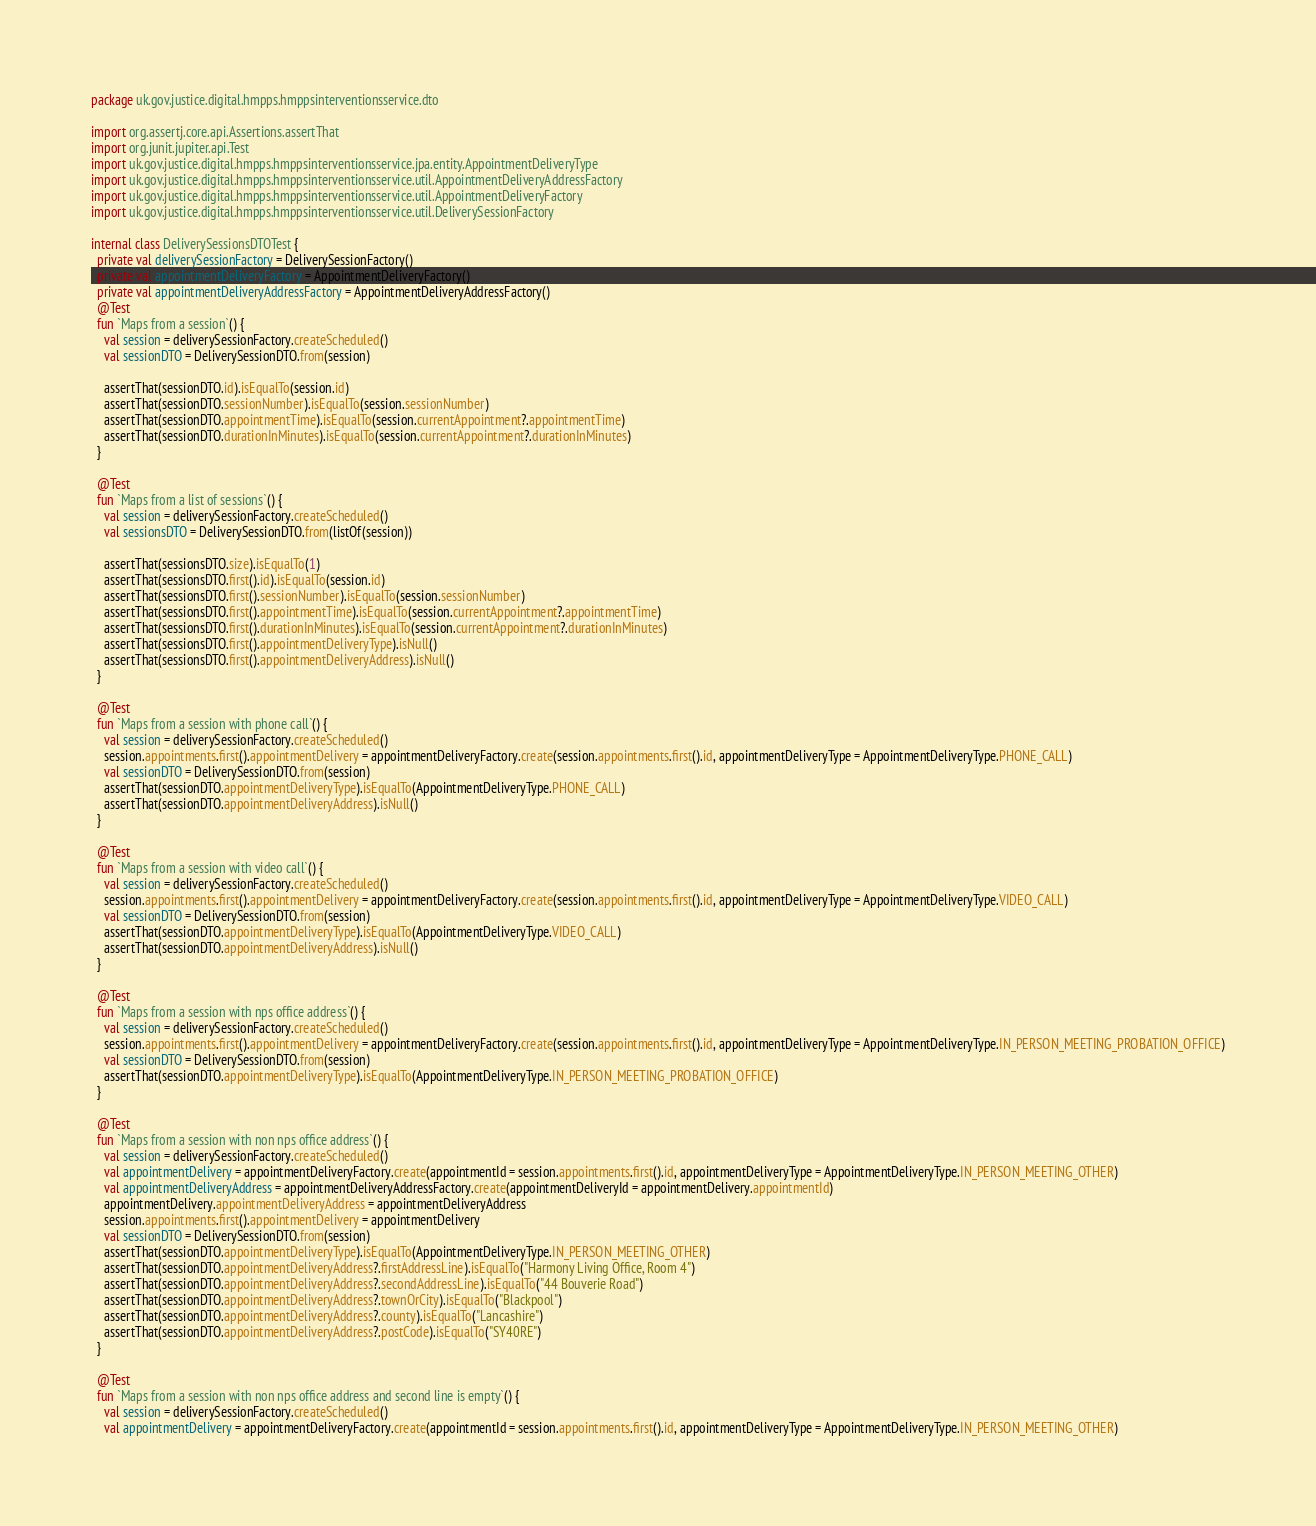Convert code to text. <code><loc_0><loc_0><loc_500><loc_500><_Kotlin_>package uk.gov.justice.digital.hmpps.hmppsinterventionsservice.dto

import org.assertj.core.api.Assertions.assertThat
import org.junit.jupiter.api.Test
import uk.gov.justice.digital.hmpps.hmppsinterventionsservice.jpa.entity.AppointmentDeliveryType
import uk.gov.justice.digital.hmpps.hmppsinterventionsservice.util.AppointmentDeliveryAddressFactory
import uk.gov.justice.digital.hmpps.hmppsinterventionsservice.util.AppointmentDeliveryFactory
import uk.gov.justice.digital.hmpps.hmppsinterventionsservice.util.DeliverySessionFactory

internal class DeliverySessionsDTOTest {
  private val deliverySessionFactory = DeliverySessionFactory()
  private val appointmentDeliveryFactory = AppointmentDeliveryFactory()
  private val appointmentDeliveryAddressFactory = AppointmentDeliveryAddressFactory()
  @Test
  fun `Maps from a session`() {
    val session = deliverySessionFactory.createScheduled()
    val sessionDTO = DeliverySessionDTO.from(session)

    assertThat(sessionDTO.id).isEqualTo(session.id)
    assertThat(sessionDTO.sessionNumber).isEqualTo(session.sessionNumber)
    assertThat(sessionDTO.appointmentTime).isEqualTo(session.currentAppointment?.appointmentTime)
    assertThat(sessionDTO.durationInMinutes).isEqualTo(session.currentAppointment?.durationInMinutes)
  }

  @Test
  fun `Maps from a list of sessions`() {
    val session = deliverySessionFactory.createScheduled()
    val sessionsDTO = DeliverySessionDTO.from(listOf(session))

    assertThat(sessionsDTO.size).isEqualTo(1)
    assertThat(sessionsDTO.first().id).isEqualTo(session.id)
    assertThat(sessionsDTO.first().sessionNumber).isEqualTo(session.sessionNumber)
    assertThat(sessionsDTO.first().appointmentTime).isEqualTo(session.currentAppointment?.appointmentTime)
    assertThat(sessionsDTO.first().durationInMinutes).isEqualTo(session.currentAppointment?.durationInMinutes)
    assertThat(sessionsDTO.first().appointmentDeliveryType).isNull()
    assertThat(sessionsDTO.first().appointmentDeliveryAddress).isNull()
  }

  @Test
  fun `Maps from a session with phone call`() {
    val session = deliverySessionFactory.createScheduled()
    session.appointments.first().appointmentDelivery = appointmentDeliveryFactory.create(session.appointments.first().id, appointmentDeliveryType = AppointmentDeliveryType.PHONE_CALL)
    val sessionDTO = DeliverySessionDTO.from(session)
    assertThat(sessionDTO.appointmentDeliveryType).isEqualTo(AppointmentDeliveryType.PHONE_CALL)
    assertThat(sessionDTO.appointmentDeliveryAddress).isNull()
  }

  @Test
  fun `Maps from a session with video call`() {
    val session = deliverySessionFactory.createScheduled()
    session.appointments.first().appointmentDelivery = appointmentDeliveryFactory.create(session.appointments.first().id, appointmentDeliveryType = AppointmentDeliveryType.VIDEO_CALL)
    val sessionDTO = DeliverySessionDTO.from(session)
    assertThat(sessionDTO.appointmentDeliveryType).isEqualTo(AppointmentDeliveryType.VIDEO_CALL)
    assertThat(sessionDTO.appointmentDeliveryAddress).isNull()
  }

  @Test
  fun `Maps from a session with nps office address`() {
    val session = deliverySessionFactory.createScheduled()
    session.appointments.first().appointmentDelivery = appointmentDeliveryFactory.create(session.appointments.first().id, appointmentDeliveryType = AppointmentDeliveryType.IN_PERSON_MEETING_PROBATION_OFFICE)
    val sessionDTO = DeliverySessionDTO.from(session)
    assertThat(sessionDTO.appointmentDeliveryType).isEqualTo(AppointmentDeliveryType.IN_PERSON_MEETING_PROBATION_OFFICE)
  }

  @Test
  fun `Maps from a session with non nps office address`() {
    val session = deliverySessionFactory.createScheduled()
    val appointmentDelivery = appointmentDeliveryFactory.create(appointmentId = session.appointments.first().id, appointmentDeliveryType = AppointmentDeliveryType.IN_PERSON_MEETING_OTHER)
    val appointmentDeliveryAddress = appointmentDeliveryAddressFactory.create(appointmentDeliveryId = appointmentDelivery.appointmentId)
    appointmentDelivery.appointmentDeliveryAddress = appointmentDeliveryAddress
    session.appointments.first().appointmentDelivery = appointmentDelivery
    val sessionDTO = DeliverySessionDTO.from(session)
    assertThat(sessionDTO.appointmentDeliveryType).isEqualTo(AppointmentDeliveryType.IN_PERSON_MEETING_OTHER)
    assertThat(sessionDTO.appointmentDeliveryAddress?.firstAddressLine).isEqualTo("Harmony Living Office, Room 4")
    assertThat(sessionDTO.appointmentDeliveryAddress?.secondAddressLine).isEqualTo("44 Bouverie Road")
    assertThat(sessionDTO.appointmentDeliveryAddress?.townOrCity).isEqualTo("Blackpool")
    assertThat(sessionDTO.appointmentDeliveryAddress?.county).isEqualTo("Lancashire")
    assertThat(sessionDTO.appointmentDeliveryAddress?.postCode).isEqualTo("SY40RE")
  }

  @Test
  fun `Maps from a session with non nps office address and second line is empty`() {
    val session = deliverySessionFactory.createScheduled()
    val appointmentDelivery = appointmentDeliveryFactory.create(appointmentId = session.appointments.first().id, appointmentDeliveryType = AppointmentDeliveryType.IN_PERSON_MEETING_OTHER)</code> 